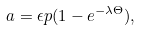<formula> <loc_0><loc_0><loc_500><loc_500>a = \epsilon p ( 1 - e ^ { - \lambda \Theta } ) ,</formula> 